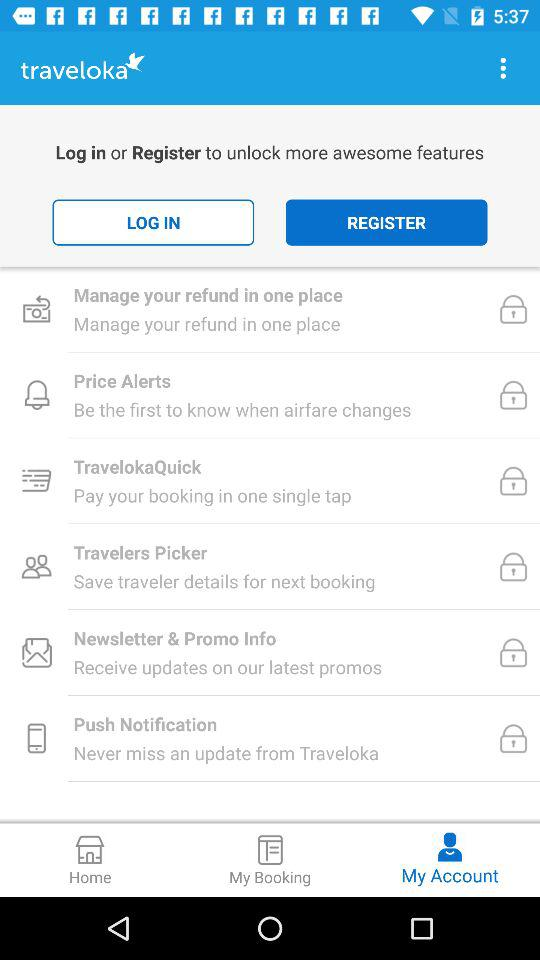What is the selected tab? The selected tab is "My Account". 